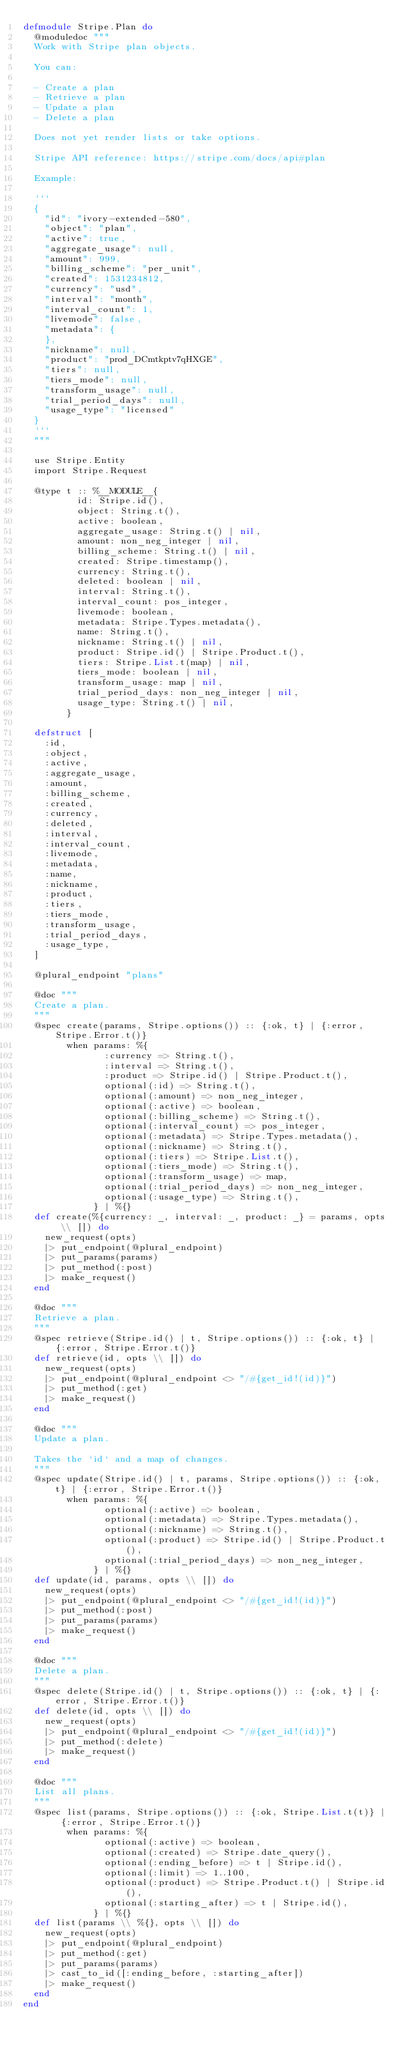<code> <loc_0><loc_0><loc_500><loc_500><_Elixir_>defmodule Stripe.Plan do
  @moduledoc """
  Work with Stripe plan objects.

  You can:

  - Create a plan
  - Retrieve a plan
  - Update a plan
  - Delete a plan

  Does not yet render lists or take options.

  Stripe API reference: https://stripe.com/docs/api#plan

  Example:

  ```
  {
    "id": "ivory-extended-580",
    "object": "plan",
    "active": true,
    "aggregate_usage": null,
    "amount": 999,
    "billing_scheme": "per_unit",
    "created": 1531234812,
    "currency": "usd",
    "interval": "month",
    "interval_count": 1,
    "livemode": false,
    "metadata": {
    },
    "nickname": null,
    "product": "prod_DCmtkptv7qHXGE",
    "tiers": null,
    "tiers_mode": null,
    "transform_usage": null,
    "trial_period_days": null,
    "usage_type": "licensed"
  }
  ```
  """

  use Stripe.Entity
  import Stripe.Request

  @type t :: %__MODULE__{
          id: Stripe.id(),
          object: String.t(),
          active: boolean,
          aggregate_usage: String.t() | nil,
          amount: non_neg_integer | nil,
          billing_scheme: String.t() | nil,
          created: Stripe.timestamp(),
          currency: String.t(),
          deleted: boolean | nil,
          interval: String.t(),
          interval_count: pos_integer,
          livemode: boolean,
          metadata: Stripe.Types.metadata(),
          name: String.t(),
          nickname: String.t() | nil,
          product: Stripe.id() | Stripe.Product.t(),
          tiers: Stripe.List.t(map) | nil,
          tiers_mode: boolean | nil,
          transform_usage: map | nil,
          trial_period_days: non_neg_integer | nil,
          usage_type: String.t() | nil,
        }

  defstruct [
    :id,
    :object,
    :active,
    :aggregate_usage,
    :amount,
    :billing_scheme,
    :created,
    :currency,
    :deleted,
    :interval,
    :interval_count,
    :livemode,
    :metadata,
    :name,
    :nickname,
    :product,
    :tiers,
    :tiers_mode,
    :transform_usage,
    :trial_period_days,
    :usage_type,
  ]

  @plural_endpoint "plans"

  @doc """
  Create a plan.
  """
  @spec create(params, Stripe.options()) :: {:ok, t} | {:error, Stripe.Error.t()}
        when params: %{
               :currency => String.t(),
               :interval => String.t(),
               :product => Stripe.id() | Stripe.Product.t(),
               optional(:id) => String.t(),
               optional(:amount) => non_neg_integer,
               optional(:active) => boolean,
               optional(:billing_scheme) => String.t(),
               optional(:interval_count) => pos_integer,
               optional(:metadata) => Stripe.Types.metadata(),
               optional(:nickname) => String.t(),
               optional(:tiers) => Stripe.List.t(),
               optional(:tiers_mode) => String.t(),
               optional(:transform_usage) => map,
               optional(:trial_period_days) => non_neg_integer,
               optional(:usage_type) => String.t(),
             } | %{}
  def create(%{currency: _, interval: _, product: _} = params, opts \\ []) do
    new_request(opts)
    |> put_endpoint(@plural_endpoint)
    |> put_params(params)
    |> put_method(:post)
    |> make_request()
  end

  @doc """
  Retrieve a plan.
  """
  @spec retrieve(Stripe.id() | t, Stripe.options()) :: {:ok, t} | {:error, Stripe.Error.t()}
  def retrieve(id, opts \\ []) do
    new_request(opts)
    |> put_endpoint(@plural_endpoint <> "/#{get_id!(id)}")
    |> put_method(:get)
    |> make_request()
  end

  @doc """
  Update a plan.

  Takes the `id` and a map of changes.
  """
  @spec update(Stripe.id() | t, params, Stripe.options()) :: {:ok, t} | {:error, Stripe.Error.t()}
        when params: %{
               optional(:active) => boolean,
               optional(:metadata) => Stripe.Types.metadata(),
               optional(:nickname) => String.t(),
               optional(:product) => Stripe.id() | Stripe.Product.t(),
               optional(:trial_period_days) => non_neg_integer,
             } | %{}
  def update(id, params, opts \\ []) do
    new_request(opts)
    |> put_endpoint(@plural_endpoint <> "/#{get_id!(id)}")
    |> put_method(:post)
    |> put_params(params)
    |> make_request()
  end

  @doc """
  Delete a plan.
  """
  @spec delete(Stripe.id() | t, Stripe.options()) :: {:ok, t} | {:error, Stripe.Error.t()}
  def delete(id, opts \\ []) do
    new_request(opts)
    |> put_endpoint(@plural_endpoint <> "/#{get_id!(id)}")
    |> put_method(:delete)
    |> make_request()
  end

  @doc """
  List all plans.
  """
  @spec list(params, Stripe.options()) :: {:ok, Stripe.List.t(t)} | {:error, Stripe.Error.t()}
        when params: %{
               optional(:active) => boolean,
               optional(:created) => Stripe.date_query(),
               optional(:ending_before) => t | Stripe.id(),
               optional(:limit) => 1..100,
               optional(:product) => Stripe.Product.t() | Stripe.id(),
               optional(:starting_after) => t | Stripe.id(),
             } | %{}
  def list(params \\ %{}, opts \\ []) do
    new_request(opts)
    |> put_endpoint(@plural_endpoint)
    |> put_method(:get)
    |> put_params(params)
    |> cast_to_id([:ending_before, :starting_after])
    |> make_request()
  end
end
</code> 